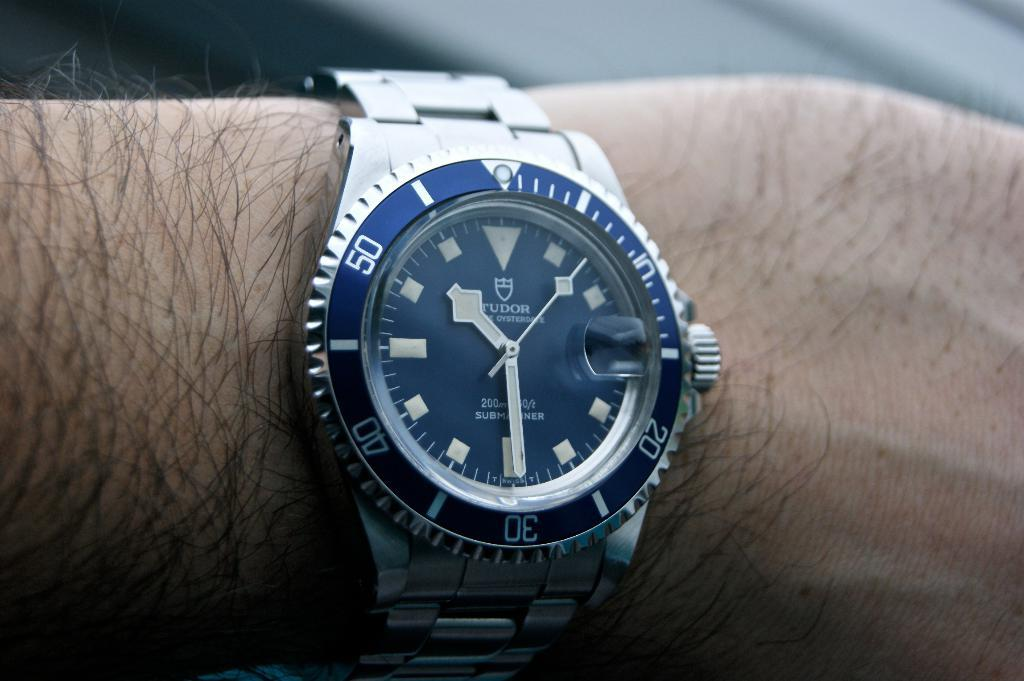<image>
Present a compact description of the photo's key features. a Tudor wrist watch on a hairy arm 